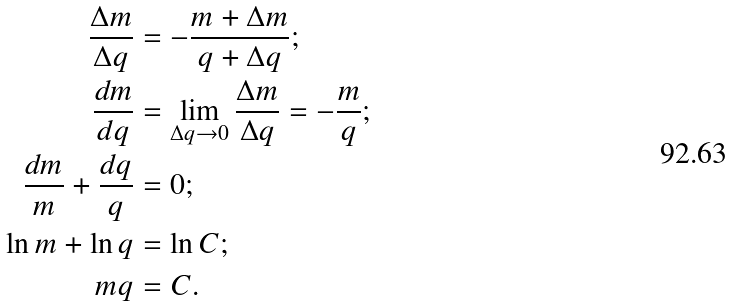Convert formula to latex. <formula><loc_0><loc_0><loc_500><loc_500>\frac { \Delta m } { \Delta q } & = - \frac { m + \Delta m } { q + \Delta q } ; \\ \frac { d m } { d q } & = \lim _ { \Delta q \rightarrow 0 } \frac { \Delta m } { \Delta q } = - \frac { m } { q } ; \\ \frac { d m } { m } + \frac { d q } { q } & = 0 ; \\ \ln m + \ln q & = \ln C ; \\ m q & = C .</formula> 